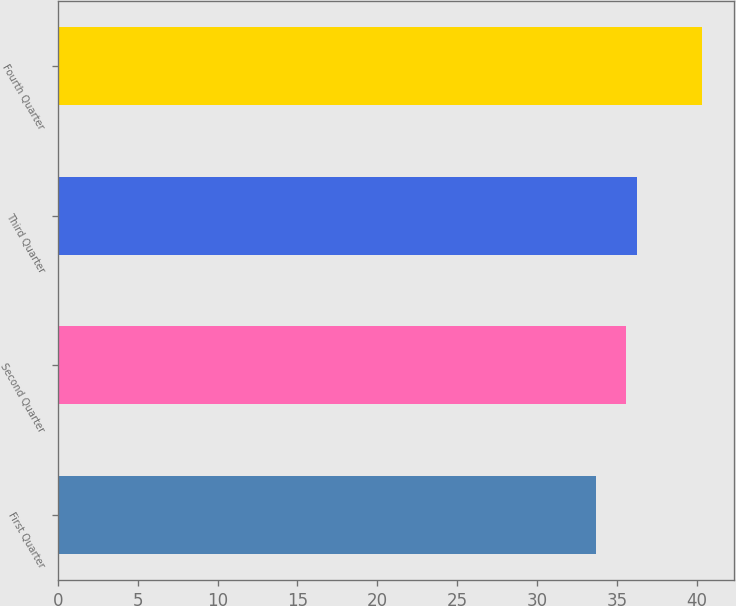Convert chart. <chart><loc_0><loc_0><loc_500><loc_500><bar_chart><fcel>First Quarter<fcel>Second Quarter<fcel>Third Quarter<fcel>Fourth Quarter<nl><fcel>33.66<fcel>35.54<fcel>36.24<fcel>40.29<nl></chart> 